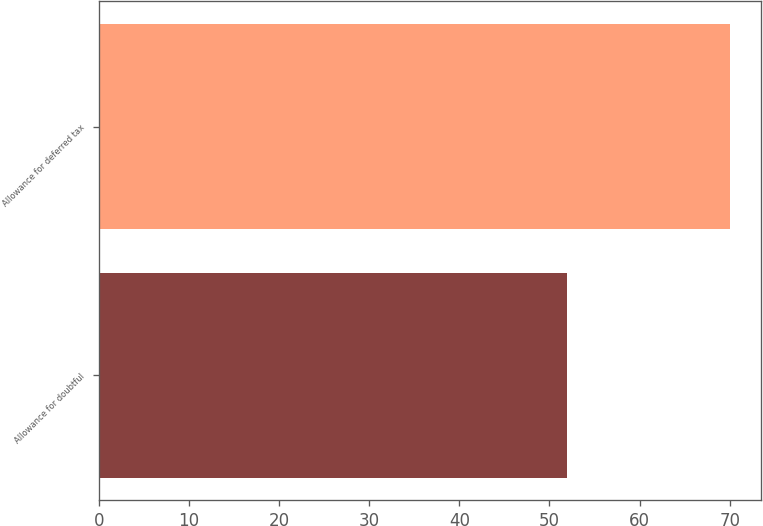<chart> <loc_0><loc_0><loc_500><loc_500><bar_chart><fcel>Allowance for doubtful<fcel>Allowance for deferred tax<nl><fcel>52<fcel>70<nl></chart> 